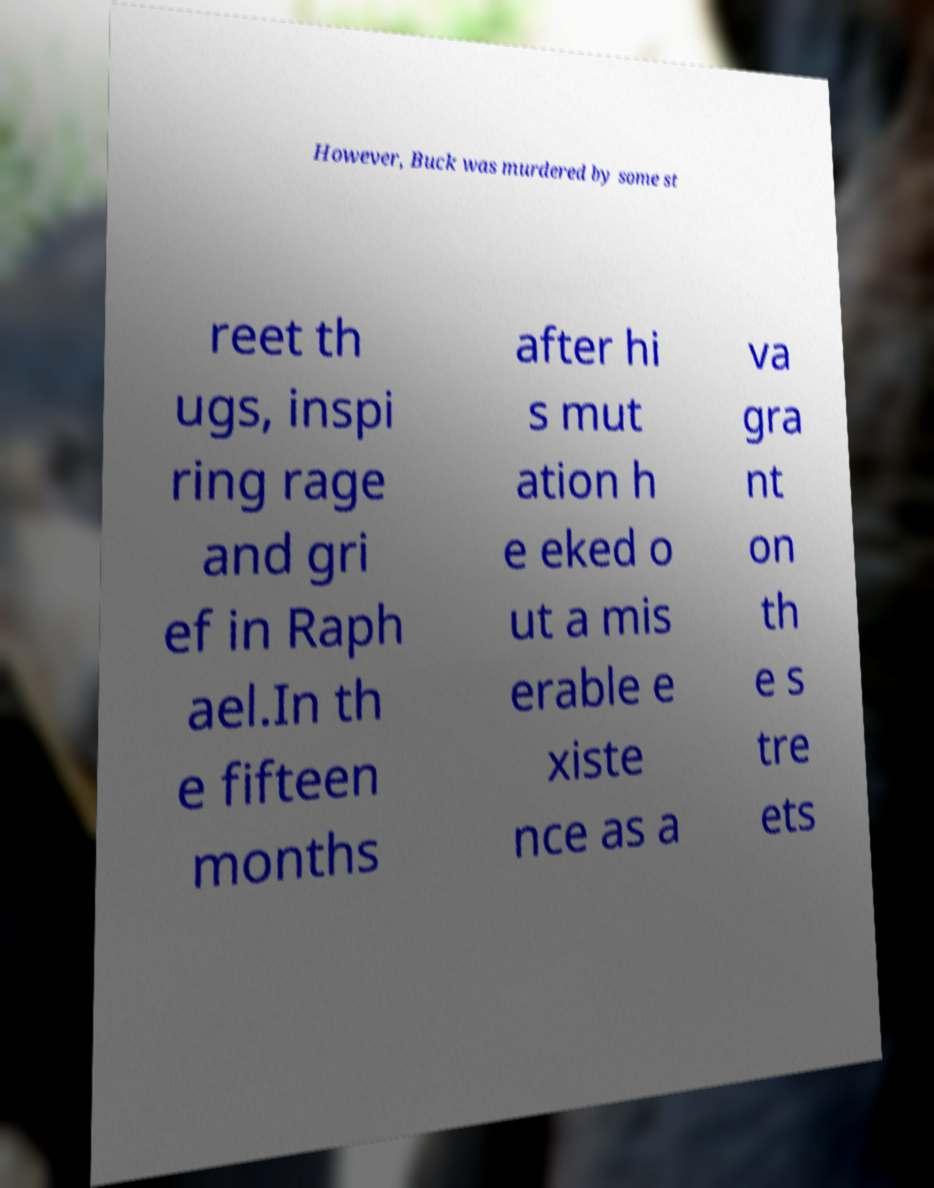Can you accurately transcribe the text from the provided image for me? However, Buck was murdered by some st reet th ugs, inspi ring rage and gri ef in Raph ael.In th e fifteen months after hi s mut ation h e eked o ut a mis erable e xiste nce as a va gra nt on th e s tre ets 